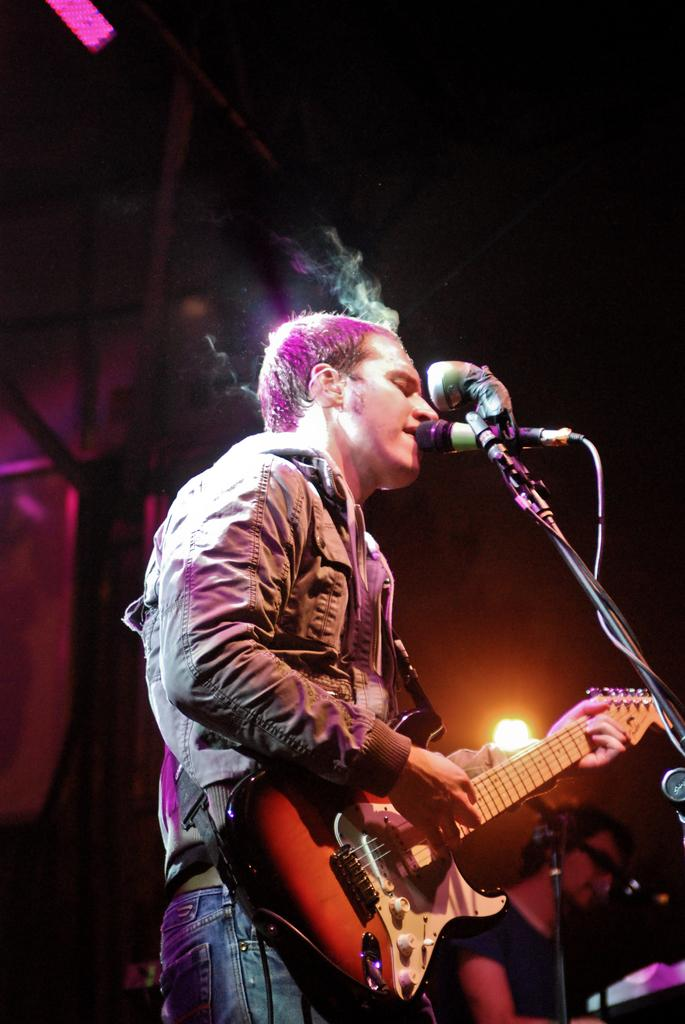What is the man in the image doing? A: The man is playing a guitar. What object is in front of the man? There is a microphone in front of the man. Can you describe the background of the image? There is light visible in the background of the image. What is the size of the farm in the image? There is no farm present in the image. 